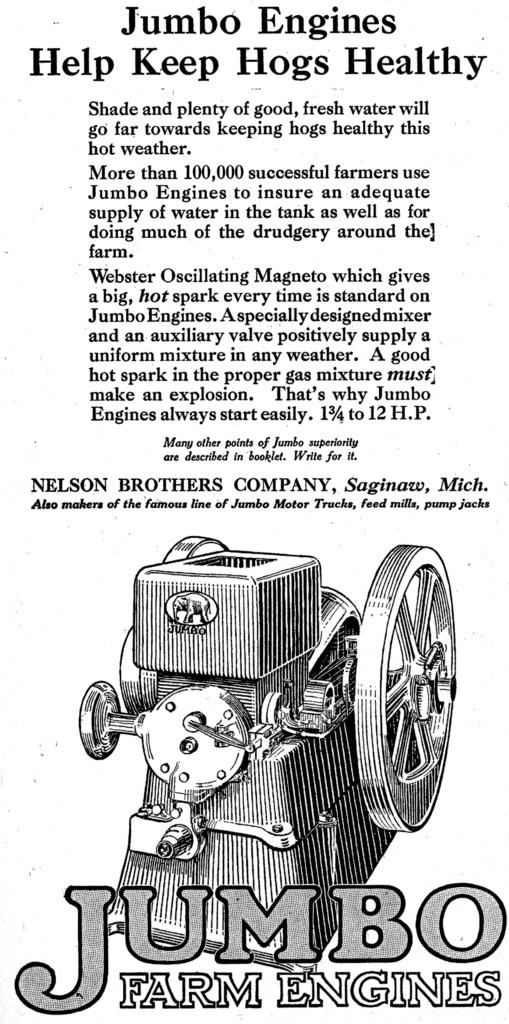What type of visual is the image? The image is a poster. What is the main subject depicted on the poster? There is a machine depicted on the poster. What else is featured on the poster besides the image of the machine? There is text present on the poster. What type of vegetable is growing on the ground in the image? There is no vegetable growing on the ground in the image, as it is a poster featuring a machine and text. How many pieces of quartz can be seen in the image? There is no quartz present in the image. 